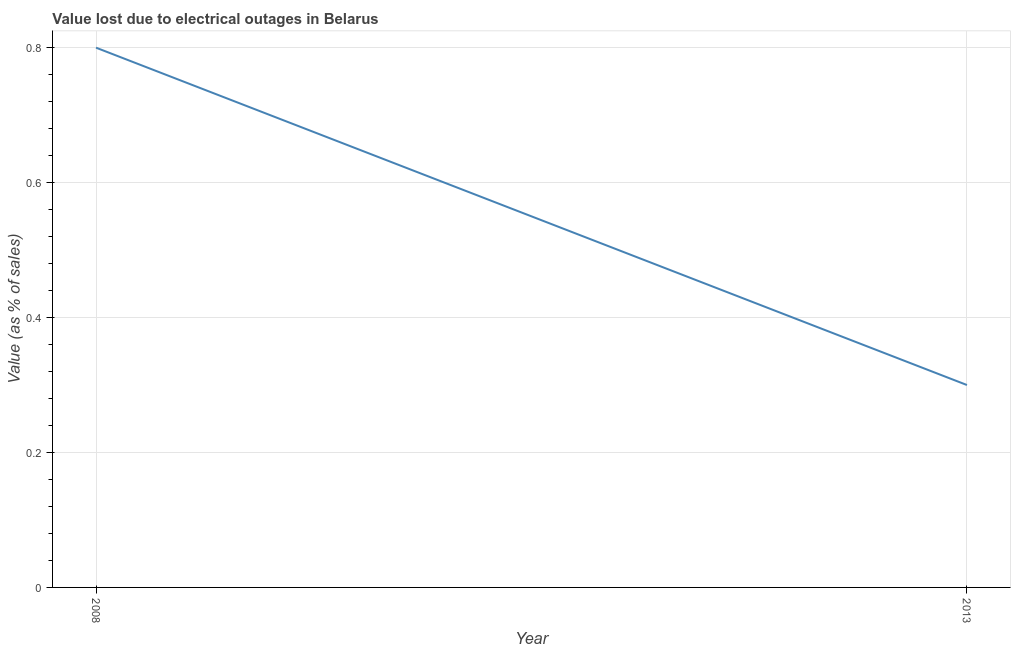What is the value lost due to electrical outages in 2008?
Make the answer very short. 0.8. Across all years, what is the minimum value lost due to electrical outages?
Offer a terse response. 0.3. In which year was the value lost due to electrical outages maximum?
Offer a very short reply. 2008. In which year was the value lost due to electrical outages minimum?
Offer a terse response. 2013. What is the sum of the value lost due to electrical outages?
Give a very brief answer. 1.1. What is the difference between the value lost due to electrical outages in 2008 and 2013?
Offer a terse response. 0.5. What is the average value lost due to electrical outages per year?
Provide a short and direct response. 0.55. What is the median value lost due to electrical outages?
Offer a very short reply. 0.55. Do a majority of the years between 2013 and 2008 (inclusive) have value lost due to electrical outages greater than 0.32 %?
Give a very brief answer. No. What is the ratio of the value lost due to electrical outages in 2008 to that in 2013?
Give a very brief answer. 2.67. Is the value lost due to electrical outages in 2008 less than that in 2013?
Ensure brevity in your answer.  No. In how many years, is the value lost due to electrical outages greater than the average value lost due to electrical outages taken over all years?
Provide a short and direct response. 1. Does the value lost due to electrical outages monotonically increase over the years?
Your answer should be compact. No. How many lines are there?
Offer a terse response. 1. Are the values on the major ticks of Y-axis written in scientific E-notation?
Ensure brevity in your answer.  No. Does the graph contain any zero values?
Offer a terse response. No. Does the graph contain grids?
Make the answer very short. Yes. What is the title of the graph?
Ensure brevity in your answer.  Value lost due to electrical outages in Belarus. What is the label or title of the X-axis?
Your answer should be very brief. Year. What is the label or title of the Y-axis?
Ensure brevity in your answer.  Value (as % of sales). What is the Value (as % of sales) in 2008?
Your answer should be compact. 0.8. What is the difference between the Value (as % of sales) in 2008 and 2013?
Ensure brevity in your answer.  0.5. What is the ratio of the Value (as % of sales) in 2008 to that in 2013?
Offer a terse response. 2.67. 